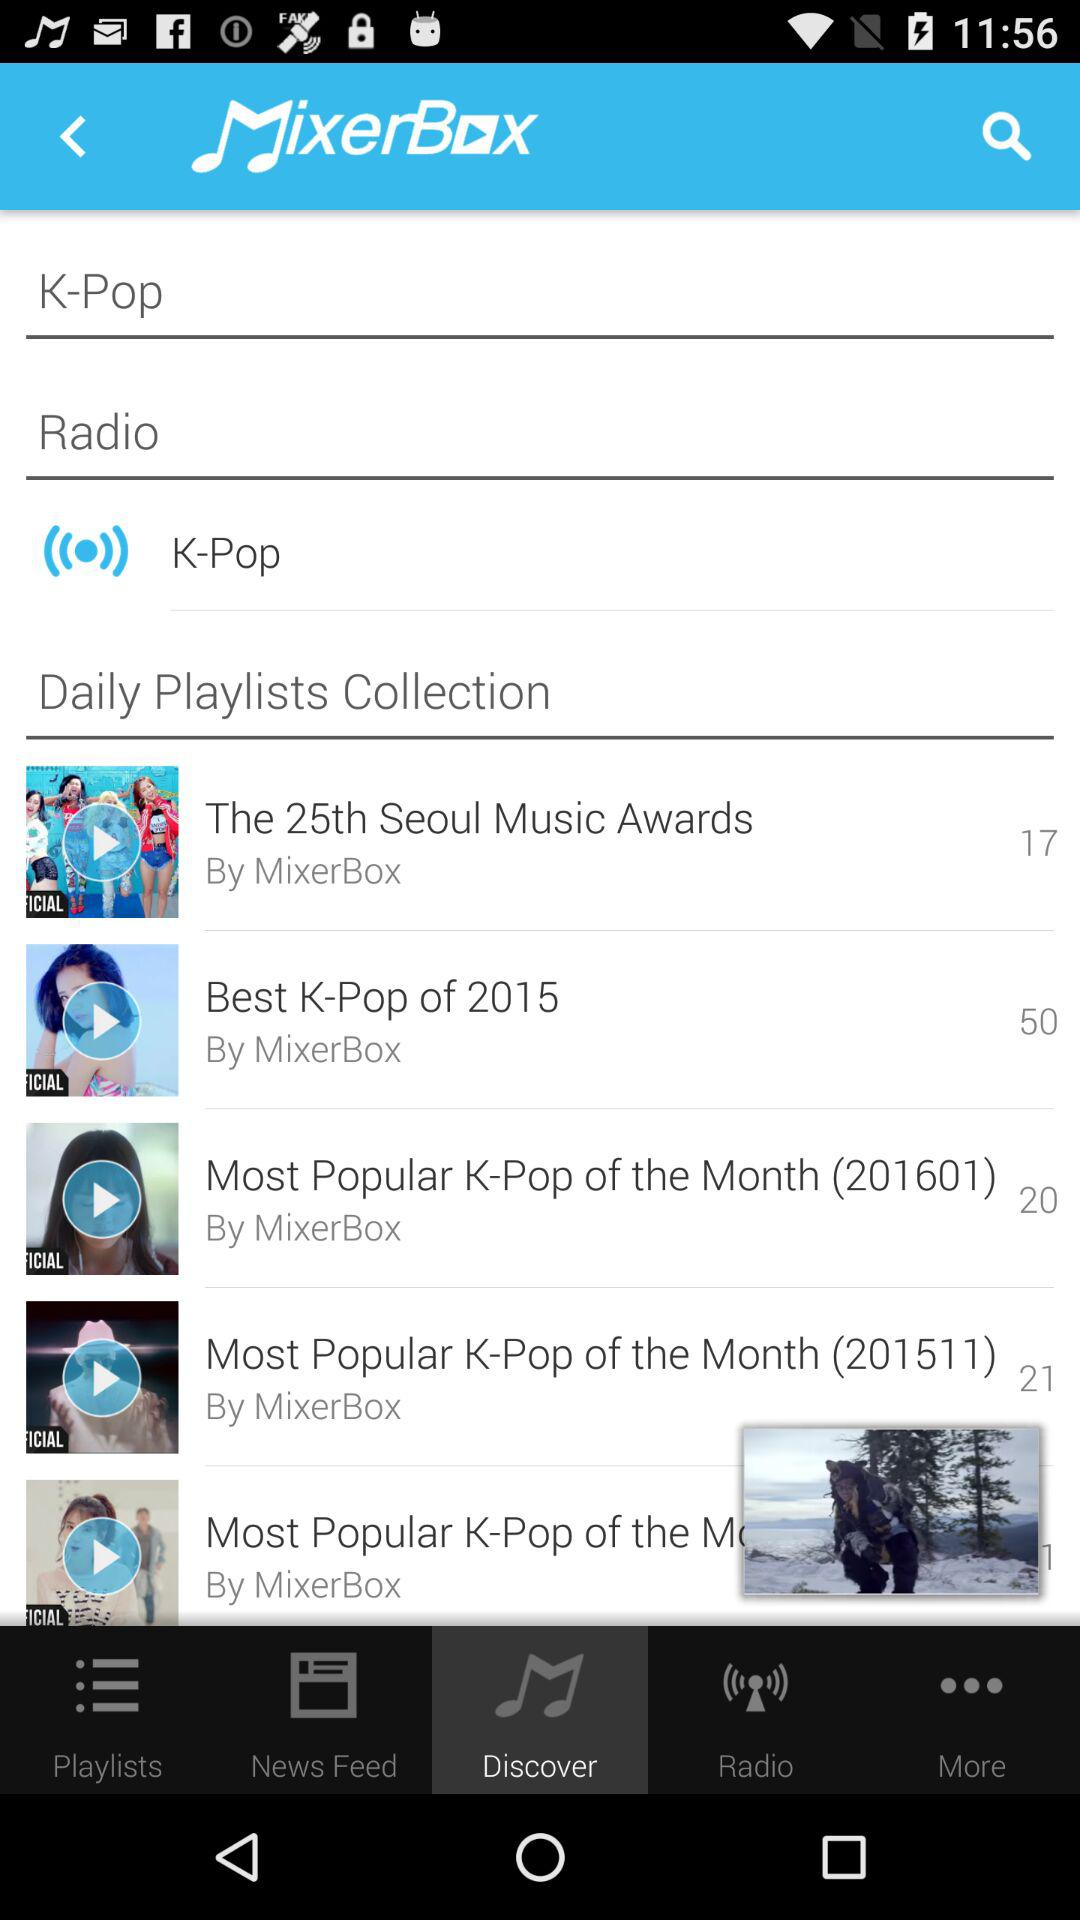What is the singer name of the 201601 song?
When the provided information is insufficient, respond with <no answer>. <no answer> 